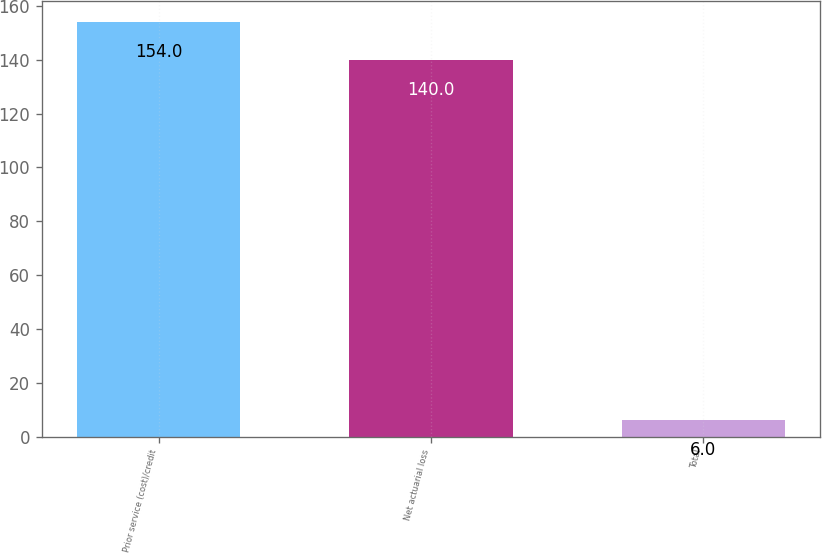<chart> <loc_0><loc_0><loc_500><loc_500><bar_chart><fcel>Prior service (cost)/credit<fcel>Net actuarial loss<fcel>Total<nl><fcel>154<fcel>140<fcel>6<nl></chart> 